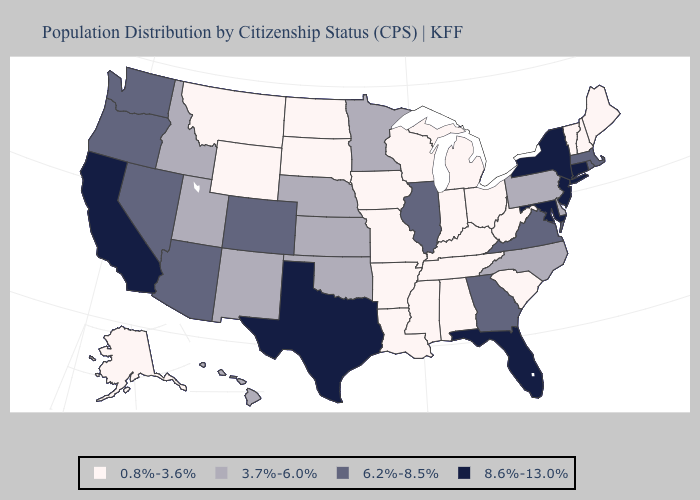Among the states that border Virginia , which have the lowest value?
Be succinct. Kentucky, Tennessee, West Virginia. Does Mississippi have the lowest value in the USA?
Quick response, please. Yes. What is the value of Texas?
Be succinct. 8.6%-13.0%. Does Alaska have the lowest value in the USA?
Give a very brief answer. Yes. Is the legend a continuous bar?
Answer briefly. No. What is the highest value in the South ?
Be succinct. 8.6%-13.0%. What is the value of Nevada?
Quick response, please. 6.2%-8.5%. Does Maryland have the highest value in the USA?
Give a very brief answer. Yes. What is the value of North Carolina?
Answer briefly. 3.7%-6.0%. Does Maine have the highest value in the USA?
Answer briefly. No. Does Utah have the lowest value in the USA?
Write a very short answer. No. Name the states that have a value in the range 6.2%-8.5%?
Answer briefly. Arizona, Colorado, Georgia, Illinois, Massachusetts, Nevada, Oregon, Rhode Island, Virginia, Washington. What is the value of Maine?
Concise answer only. 0.8%-3.6%. Which states have the lowest value in the MidWest?
Answer briefly. Indiana, Iowa, Michigan, Missouri, North Dakota, Ohio, South Dakota, Wisconsin. Does Vermont have the lowest value in the USA?
Give a very brief answer. Yes. 